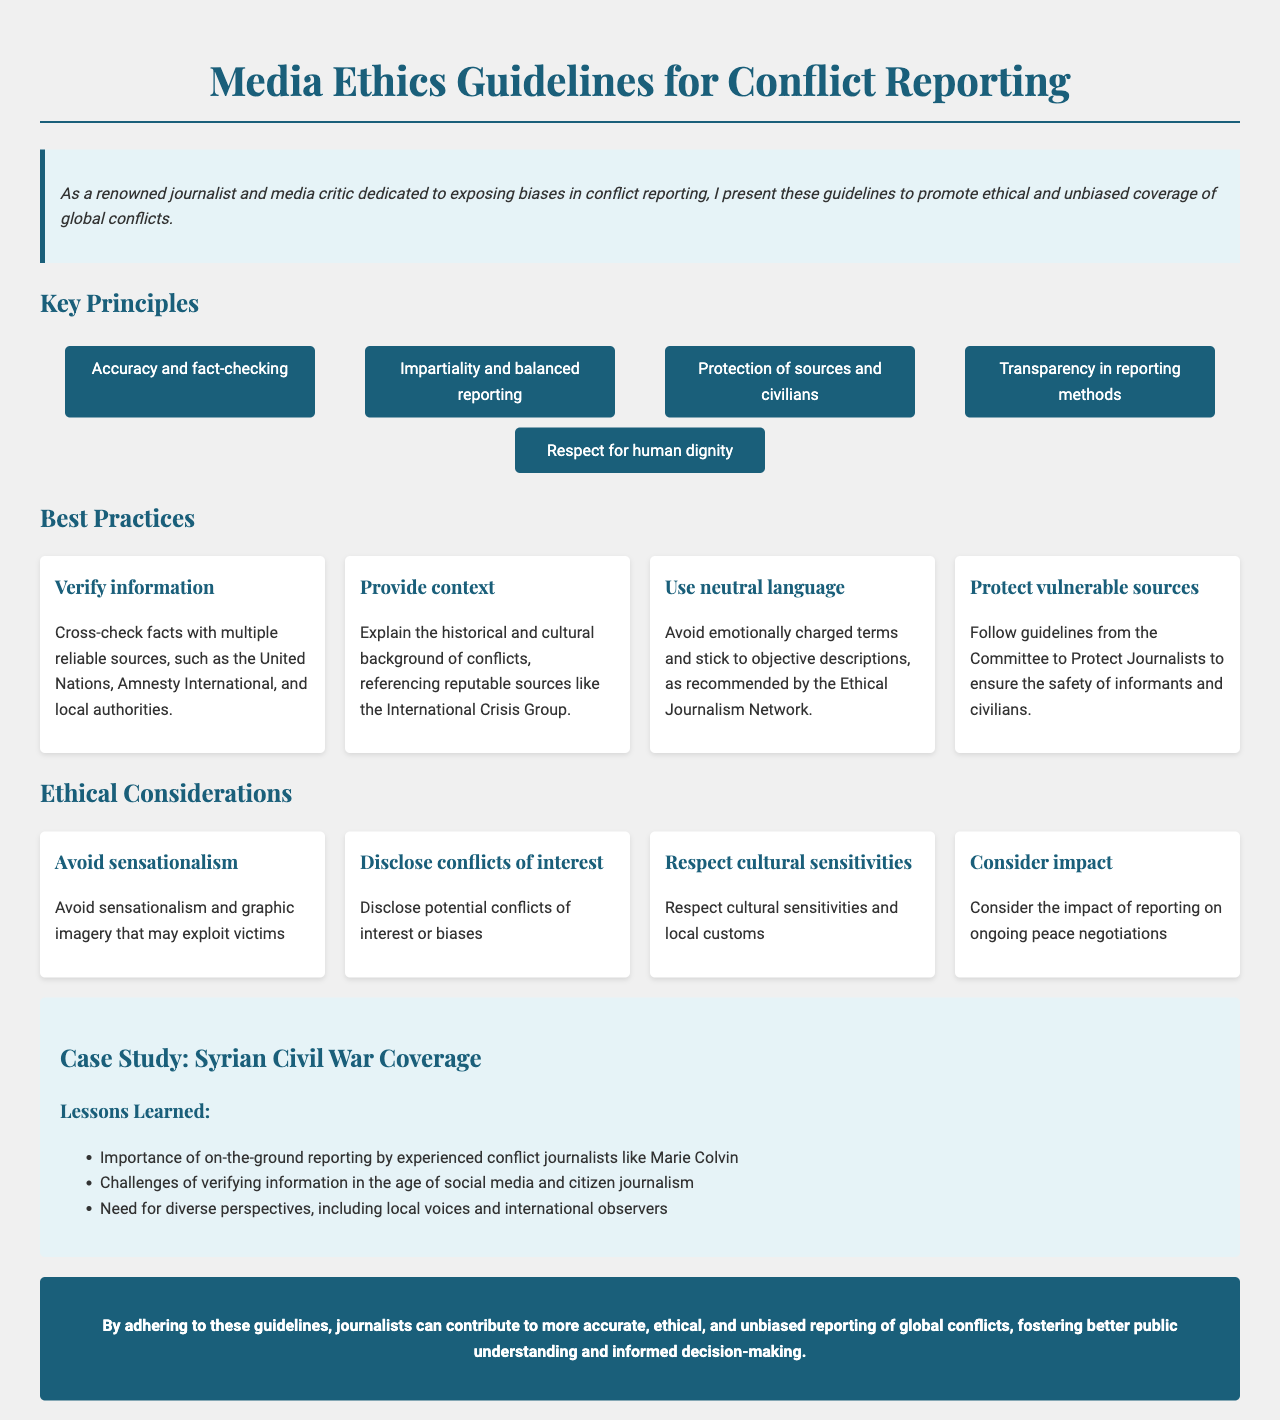What is the title of the document? The title is prominently displayed at the top of the document, indicating the subject it covers.
Answer: Media Ethics Guidelines for Conflict Reporting What principle emphasizes the need for balanced reporting? The key principles section includes a principle that specifically mentions balanced reporting.
Answer: Impartiality and balanced reporting Name one organization recommended for cross-checking facts. The document lists organizations that are reliable sources for verifying information.
Answer: United Nations What is one suggested best practice for journalists? The best practices section outlines specific actions that journalists should take to ensure ethical reporting.
Answer: Verify information What is a key ethical consideration regarding sensationalism? The ethical considerations section includes a specific point about avoiding sensationalism.
Answer: Avoid sensationalism Who is mentioned in the case study as an experienced conflict journalist? The case study includes the name of a noteworthy journalist known for their reporting in conflict zones.
Answer: Marie Colvin What does the document suggest regarding cultural sensitivities? The ethical considerations section highlights an important aspect of respecting other cultures in conflict reporting.
Answer: Respect cultural sensitivities How many key principles are listed in the document? The key principles section presents a total of five principles that guide ethical reporting.
Answer: Five What is the color of the background for the introduction section? The document describes the aesthetic elements and color schemes used, including the introduction section.
Answer: Light blue 